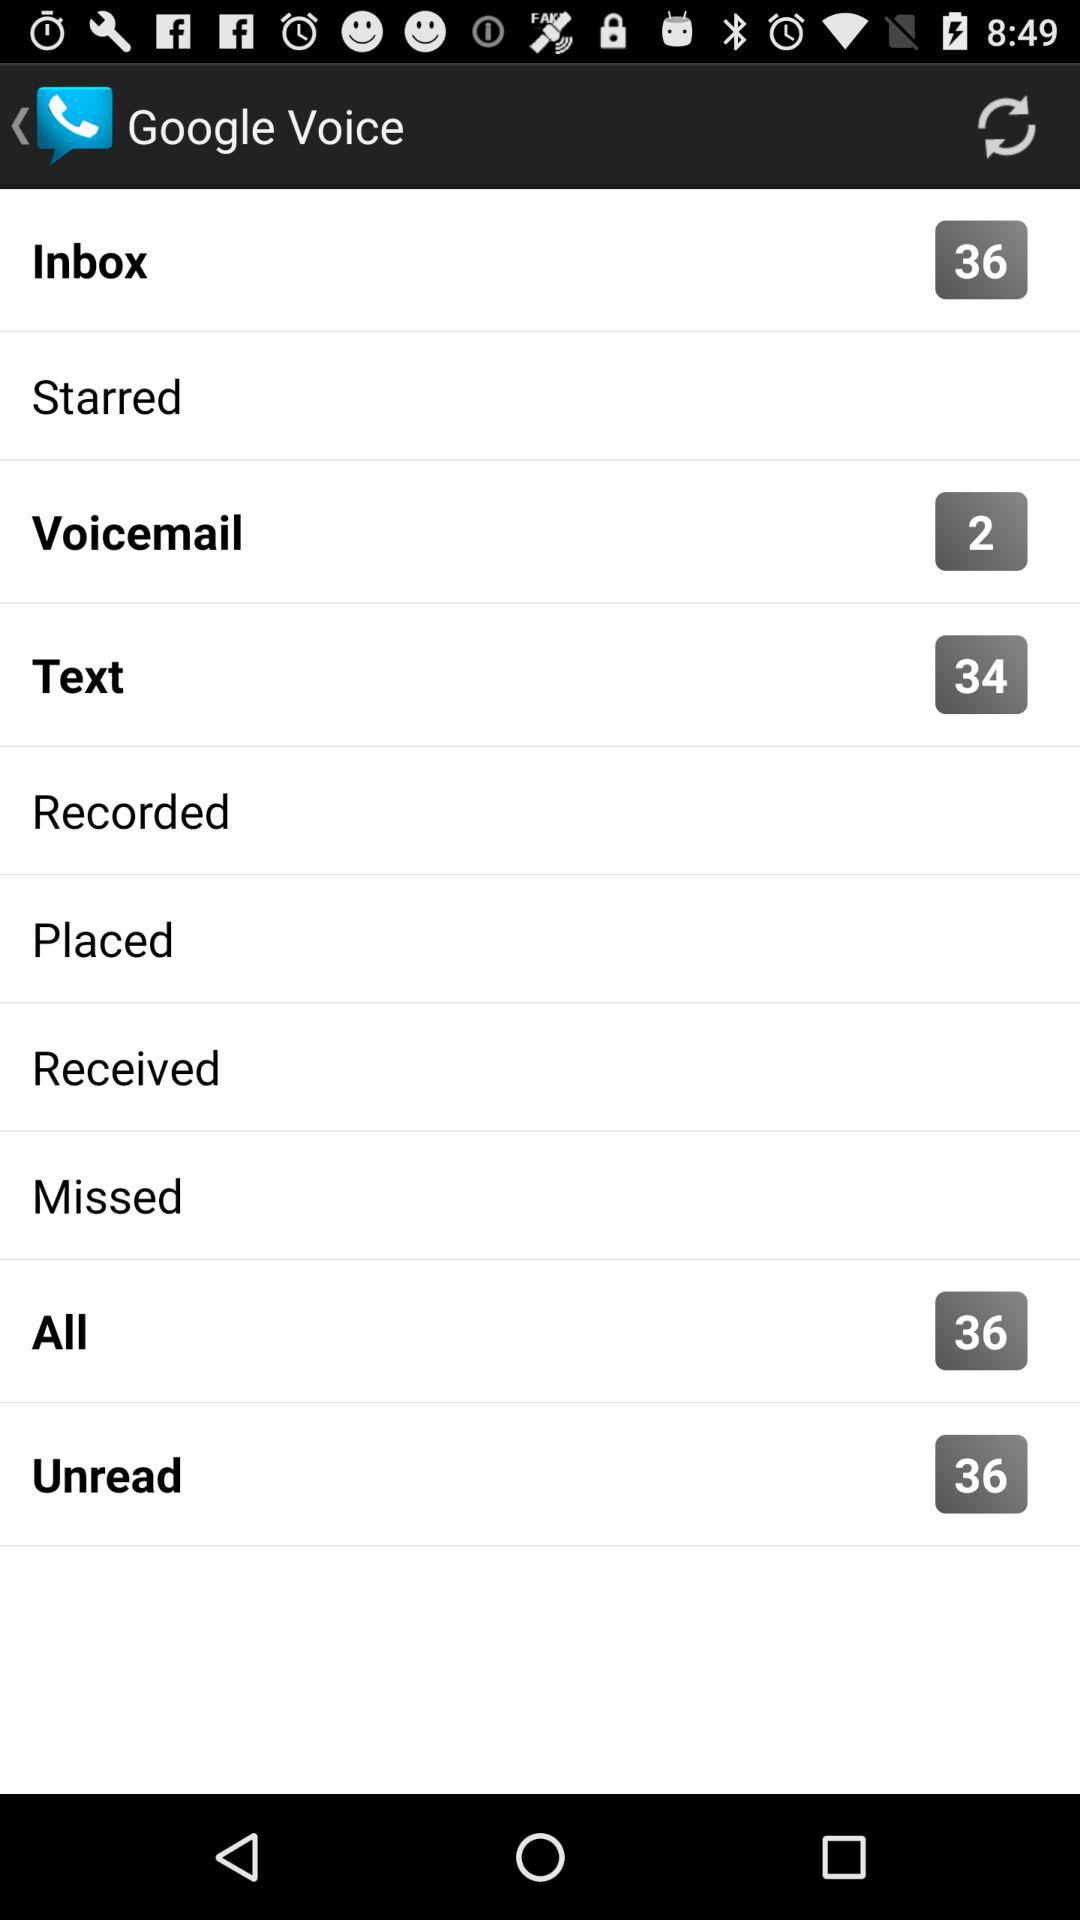How many unread messages are shown? There are 36 unread messages. 